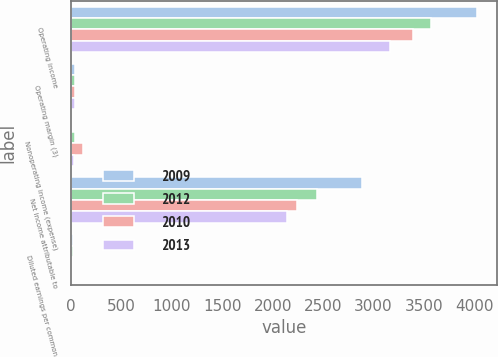Convert chart to OTSL. <chart><loc_0><loc_0><loc_500><loc_500><stacked_bar_chart><ecel><fcel>Operating income<fcel>Operating margin (3)<fcel>Nonoperating income (expense)<fcel>Net income attributable to<fcel>Diluted earnings per common<nl><fcel>2009<fcel>4024<fcel>41.4<fcel>7<fcel>2882<fcel>16.58<nl><fcel>2012<fcel>3574<fcel>40.4<fcel>42<fcel>2438<fcel>13.68<nl><fcel>2010<fcel>3392<fcel>39.7<fcel>113<fcel>2239<fcel>11.85<nl><fcel>2013<fcel>3167<fcel>39.3<fcel>25<fcel>2139<fcel>10.94<nl></chart> 